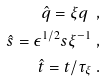<formula> <loc_0><loc_0><loc_500><loc_500>\hat { q } = \xi q \ , \\ \hat { s } = \epsilon ^ { 1 / 2 } s \xi ^ { - 1 } \ , \\ \hat { t } = t / \tau _ { \xi } \ .</formula> 